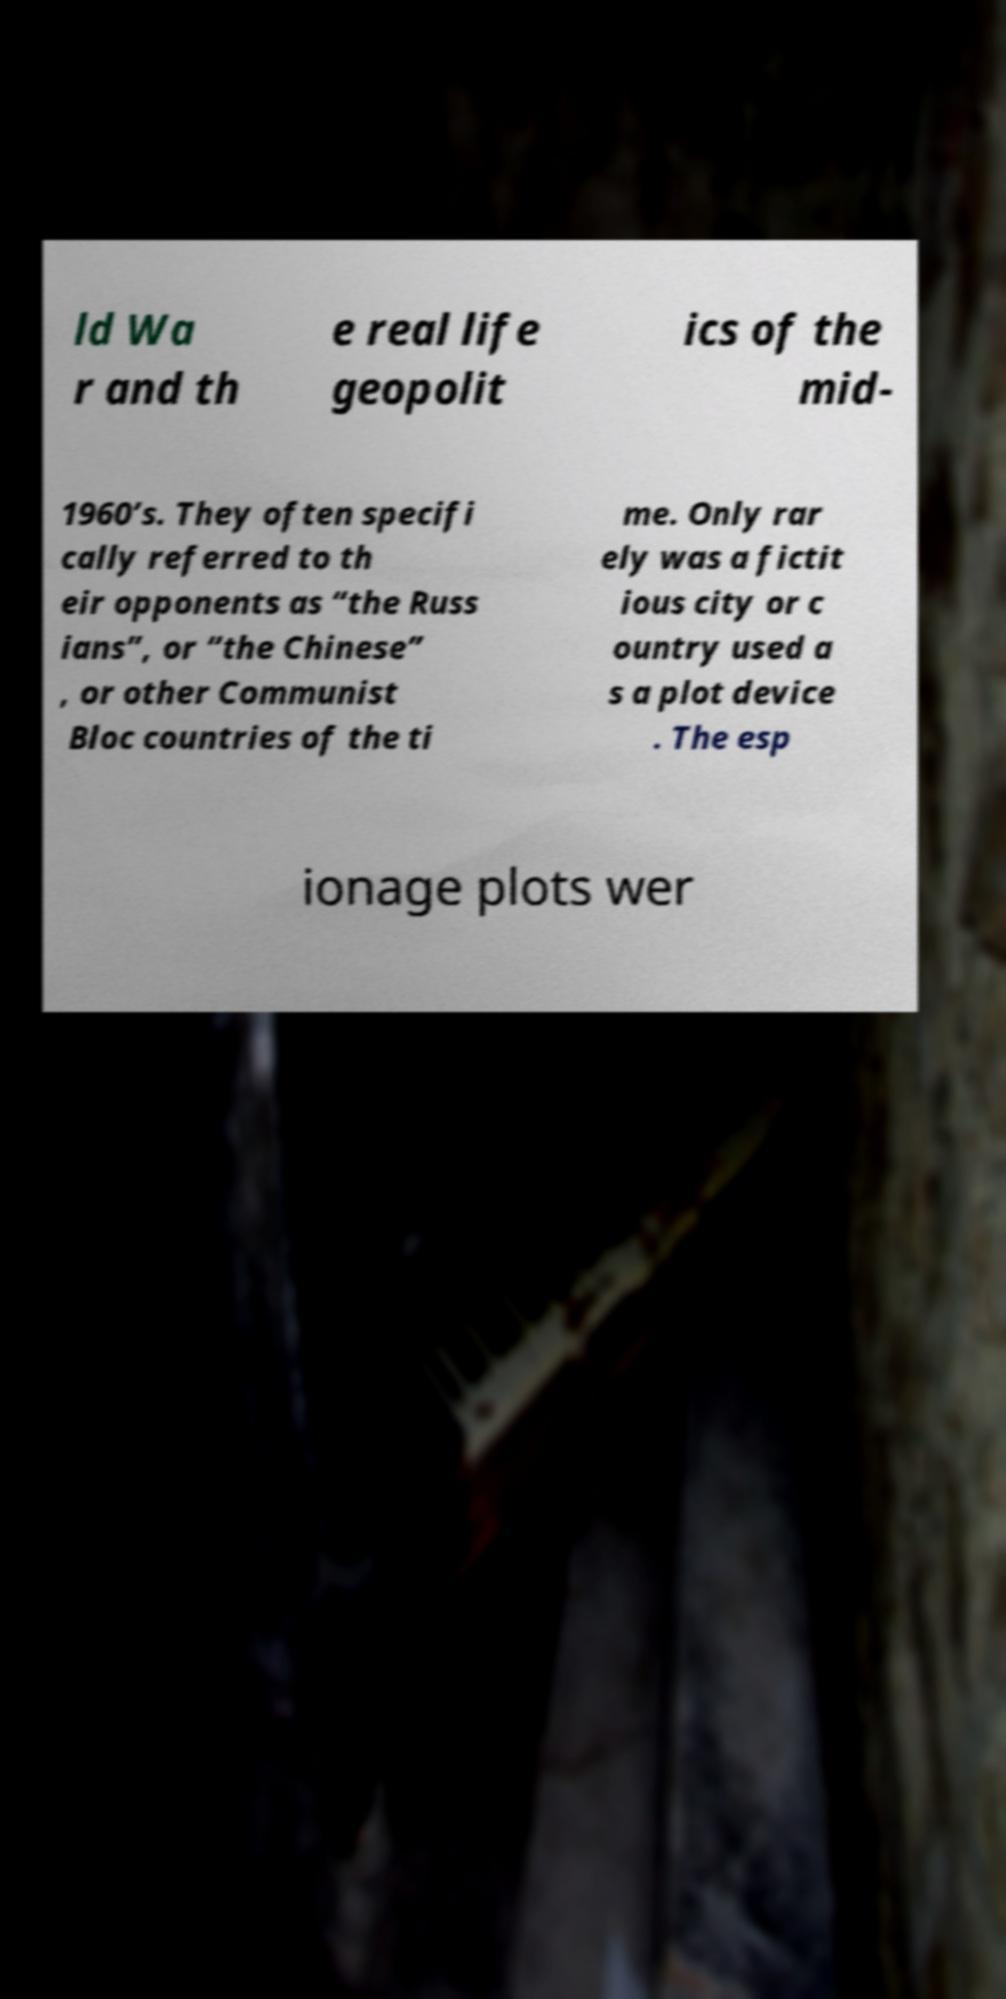Could you extract and type out the text from this image? ld Wa r and th e real life geopolit ics of the mid- 1960’s. They often specifi cally referred to th eir opponents as “the Russ ians”, or “the Chinese” , or other Communist Bloc countries of the ti me. Only rar ely was a fictit ious city or c ountry used a s a plot device . The esp ionage plots wer 